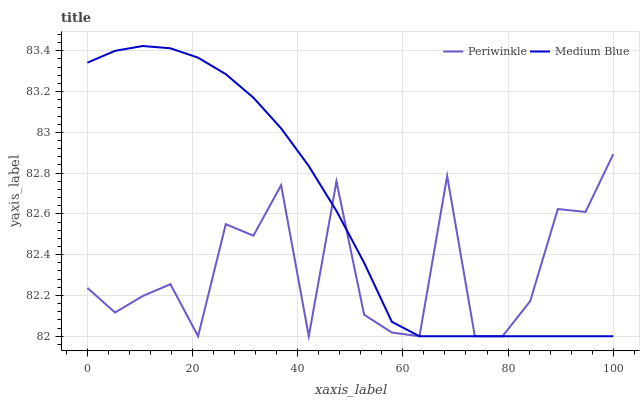Does Periwinkle have the minimum area under the curve?
Answer yes or no. Yes. Does Medium Blue have the maximum area under the curve?
Answer yes or no. Yes. Does Periwinkle have the maximum area under the curve?
Answer yes or no. No. Is Medium Blue the smoothest?
Answer yes or no. Yes. Is Periwinkle the roughest?
Answer yes or no. Yes. Is Periwinkle the smoothest?
Answer yes or no. No. Does Medium Blue have the lowest value?
Answer yes or no. Yes. Does Medium Blue have the highest value?
Answer yes or no. Yes. Does Periwinkle have the highest value?
Answer yes or no. No. Does Medium Blue intersect Periwinkle?
Answer yes or no. Yes. Is Medium Blue less than Periwinkle?
Answer yes or no. No. Is Medium Blue greater than Periwinkle?
Answer yes or no. No. 